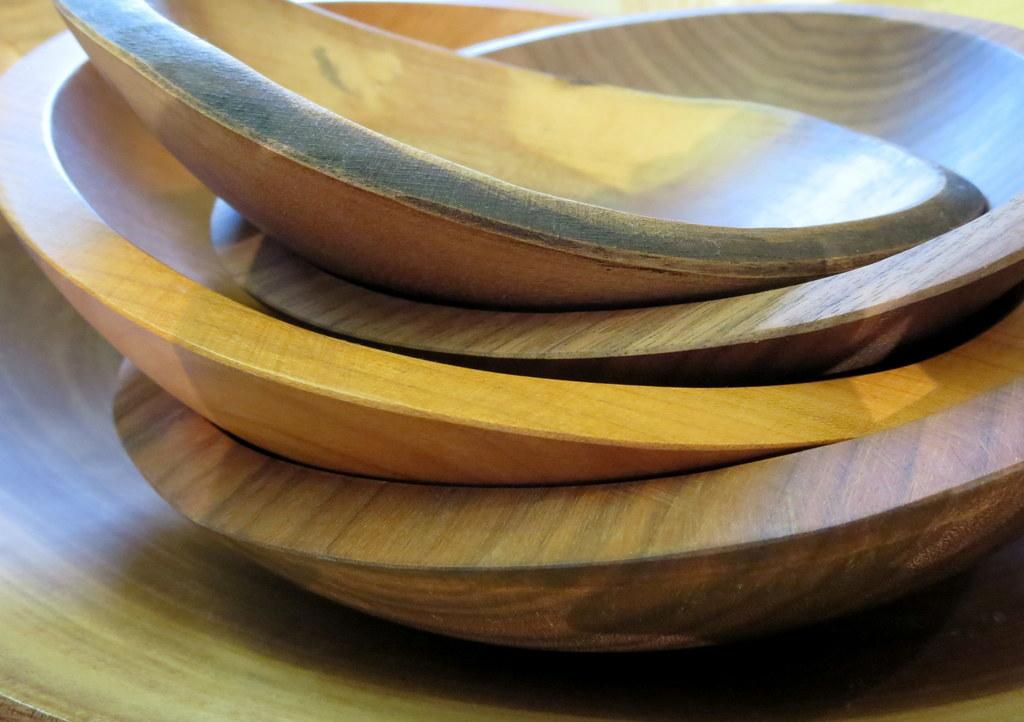What material is the plank in the image made of? The wooden plank in the image is made of wood. What objects are placed on the wooden plank? There are wooden bowls on the wooden plank. How are the wooden bowls arranged on the plank? The wooden bowls are stacked one on top of the other. Where is the tent located in the image? There is no tent present in the image. What type of airport can be seen in the image? There is no airport present in the image. 